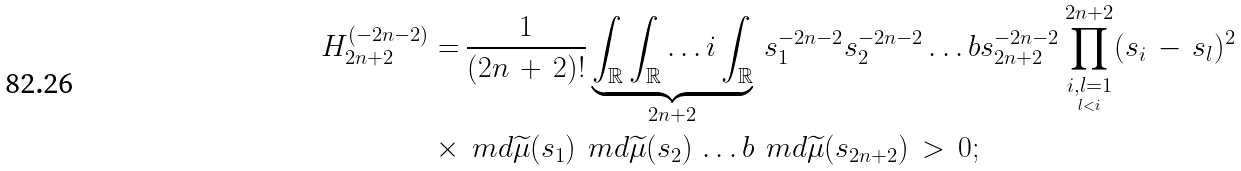Convert formula to latex. <formula><loc_0><loc_0><loc_500><loc_500>H ^ { ( - 2 n - 2 ) } _ { 2 n + 2 } = & \, \frac { 1 } { ( 2 n \, + \, 2 ) ! } \underbrace { \int _ { \mathbb { R } } \int _ { \mathbb { R } } \dots i \int _ { \mathbb { R } } } _ { 2 n + 2 } \, s _ { 1 } ^ { - 2 n - 2 } s _ { 2 } ^ { - 2 n - 2 } \dots b s _ { 2 n + 2 } ^ { - 2 n - 2 } \prod _ { \underset { l < i } { i , l = 1 } } ^ { 2 n + 2 } ( s _ { i } \, - \, s _ { l } ) ^ { 2 } \\ \times & \, \ m d \widetilde { \mu } ( s _ { 1 } ) \, \ m d \widetilde { \mu } ( s _ { 2 } ) \, \dots b \, \ m d \widetilde { \mu } ( s _ { 2 n + 2 } ) \, > \, 0 ;</formula> 